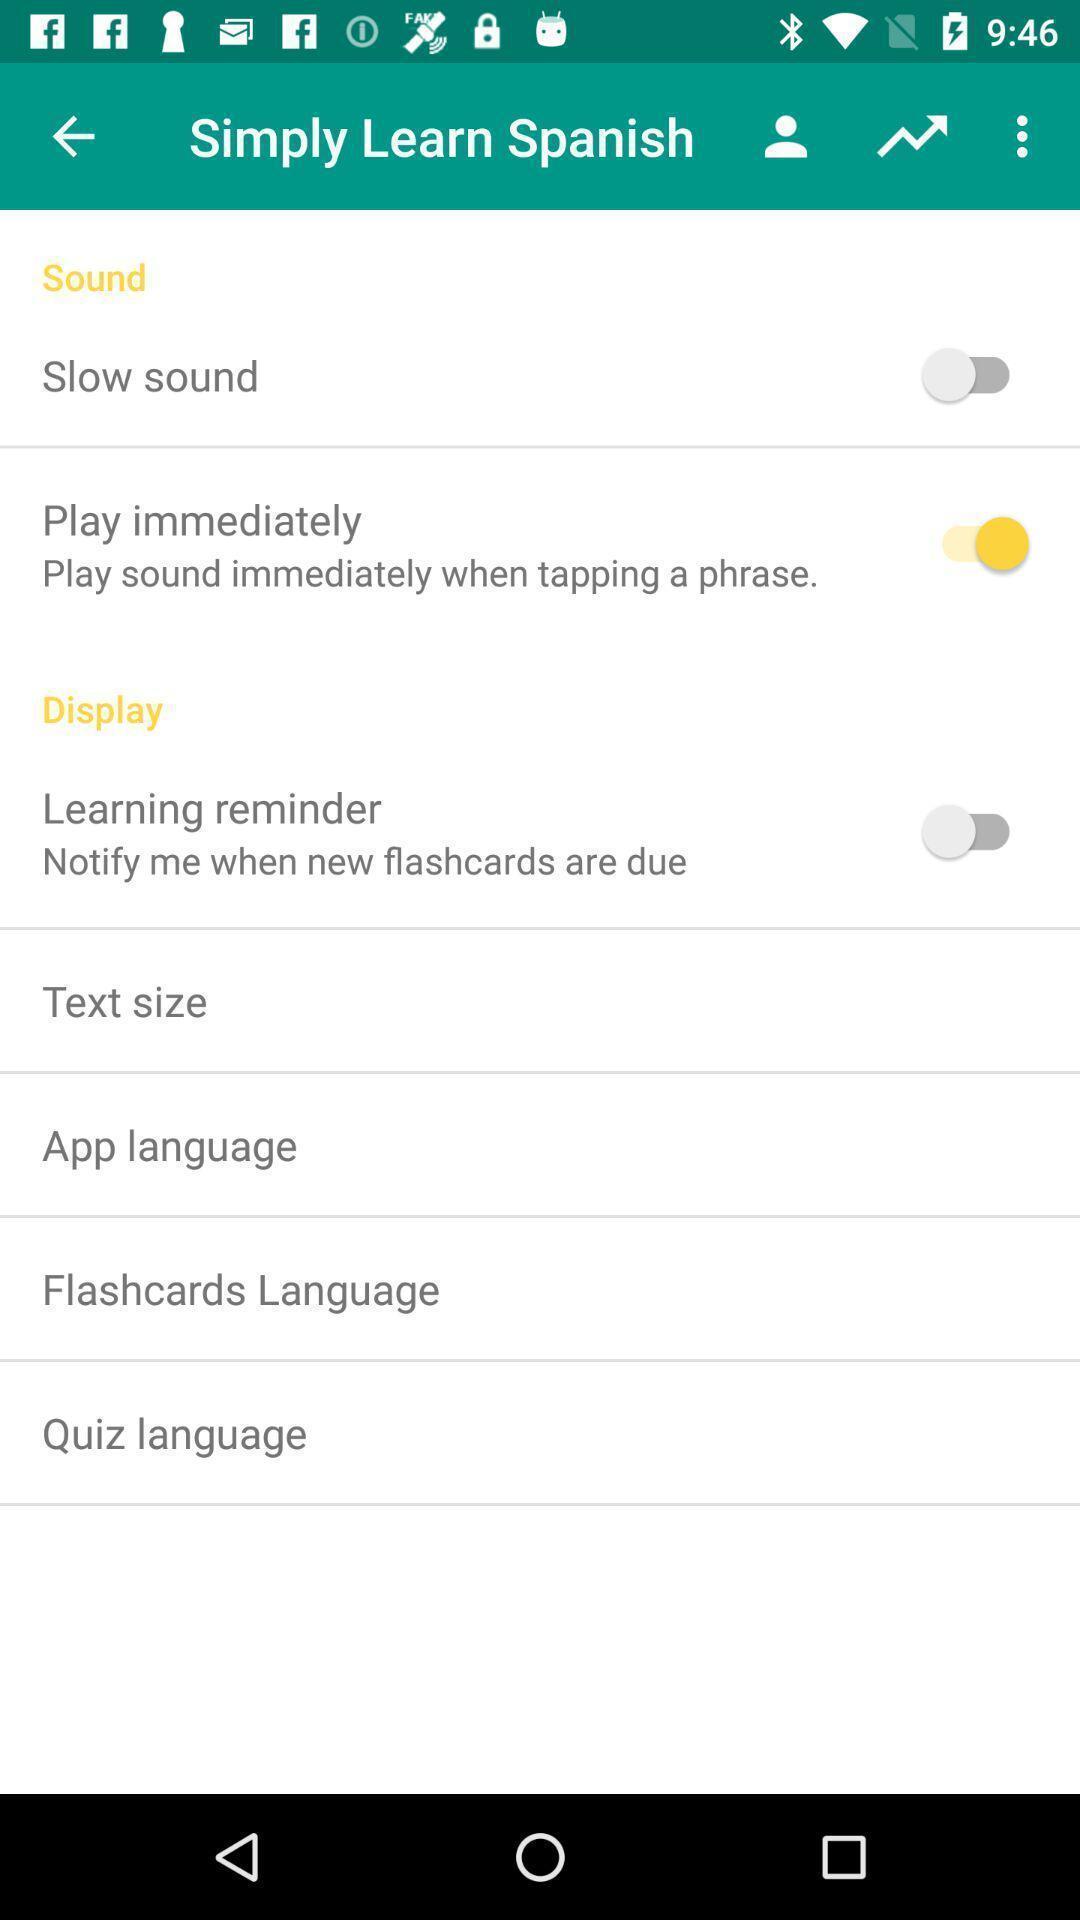Provide a detailed account of this screenshot. Screen displaying the list of features with toggle icons. 